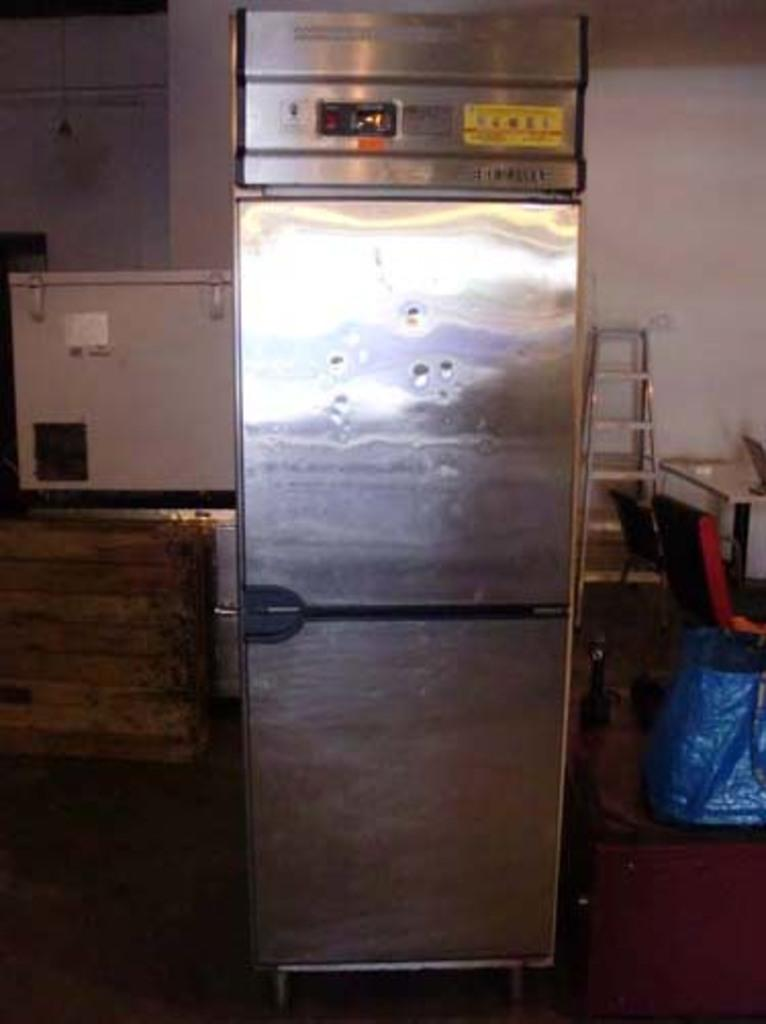Provide a one-sentence caption for the provided image. A picture of a fridge, with no discernible text in it. 